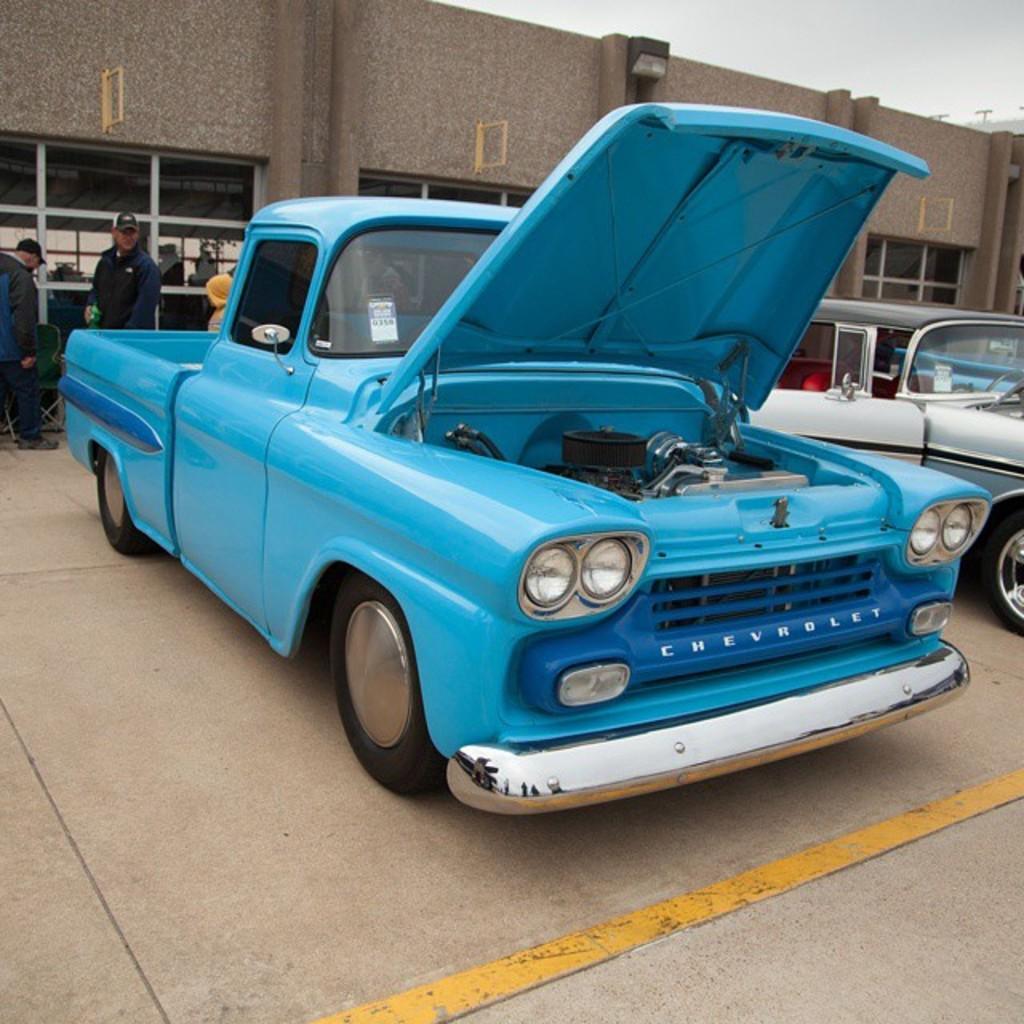How would you summarize this image in a sentence or two? In the image I can see vehicles on the road. The vehicle on the left side is blue in color. In the background I can see people, a building, the sky and some other objects. 